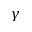Convert formula to latex. <formula><loc_0><loc_0><loc_500><loc_500>\gamma</formula> 